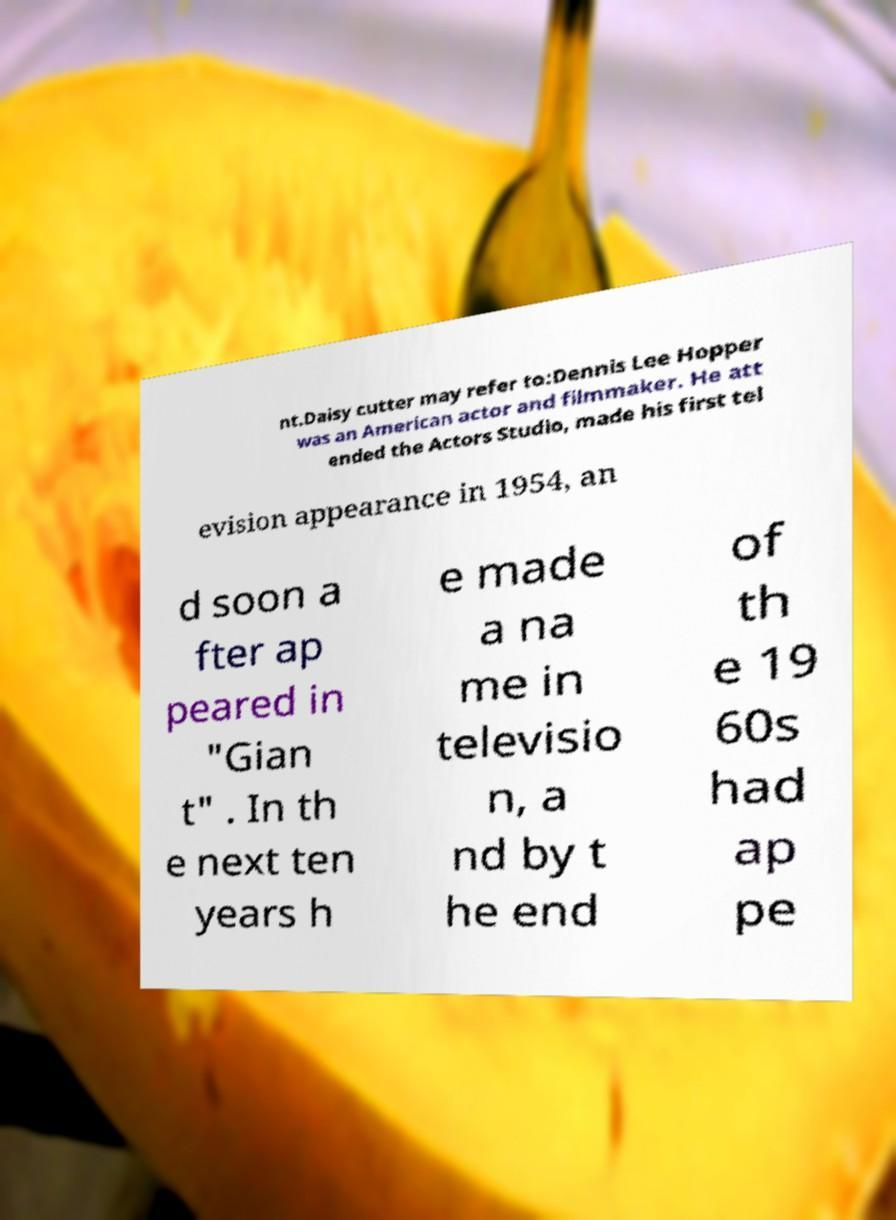Can you accurately transcribe the text from the provided image for me? nt.Daisy cutter may refer to:Dennis Lee Hopper was an American actor and filmmaker. He att ended the Actors Studio, made his first tel evision appearance in 1954, an d soon a fter ap peared in "Gian t" . In th e next ten years h e made a na me in televisio n, a nd by t he end of th e 19 60s had ap pe 